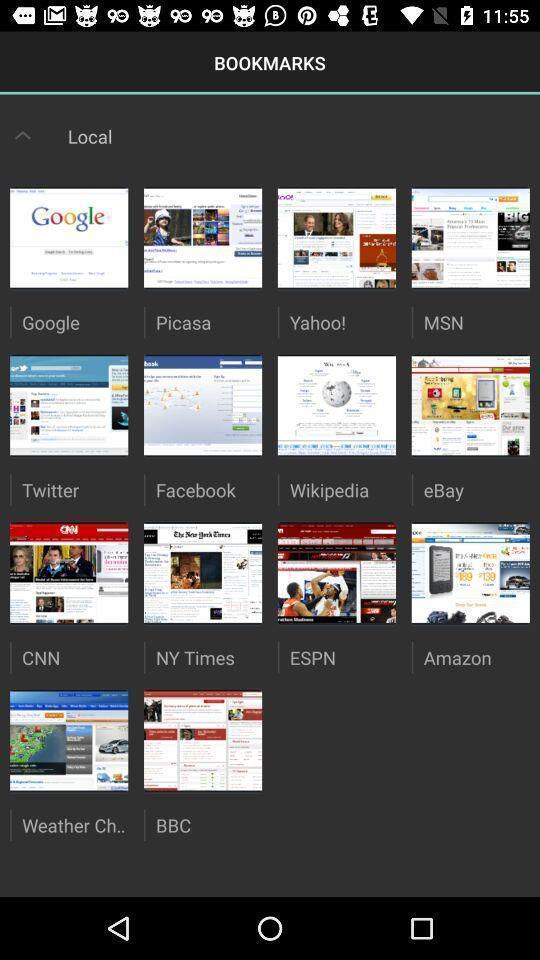Give me a summary of this screen capture. Screen displaying the bookmarks page with folders. 